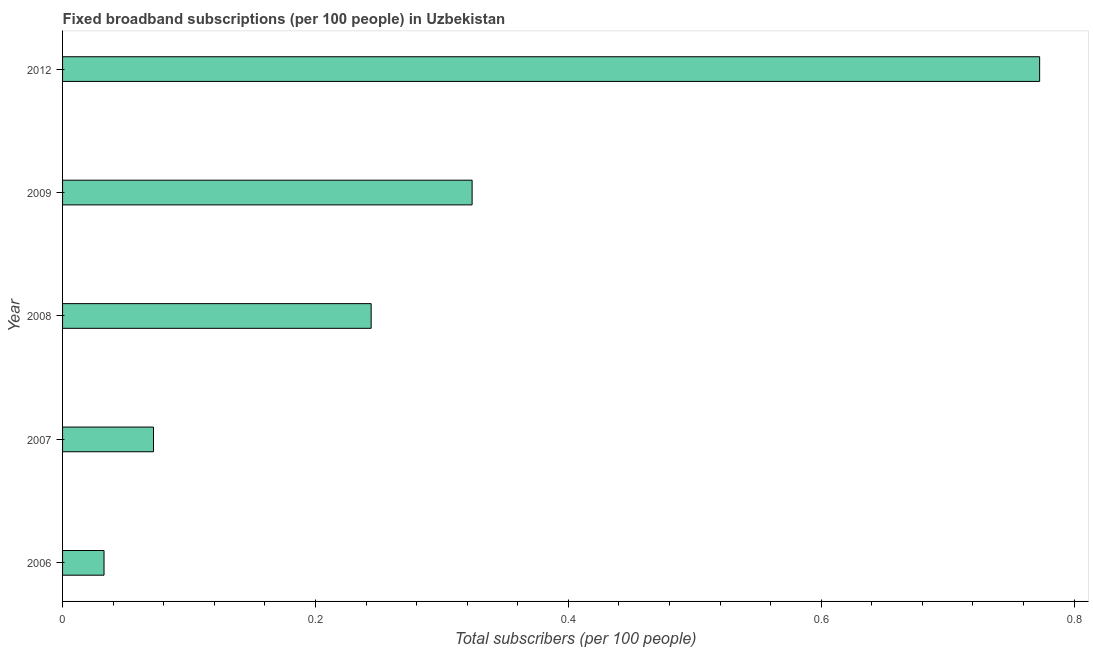Does the graph contain any zero values?
Offer a very short reply. No. Does the graph contain grids?
Provide a short and direct response. No. What is the title of the graph?
Offer a very short reply. Fixed broadband subscriptions (per 100 people) in Uzbekistan. What is the label or title of the X-axis?
Keep it short and to the point. Total subscribers (per 100 people). What is the label or title of the Y-axis?
Provide a succinct answer. Year. What is the total number of fixed broadband subscriptions in 2008?
Your response must be concise. 0.24. Across all years, what is the maximum total number of fixed broadband subscriptions?
Give a very brief answer. 0.77. Across all years, what is the minimum total number of fixed broadband subscriptions?
Your answer should be very brief. 0.03. In which year was the total number of fixed broadband subscriptions maximum?
Give a very brief answer. 2012. What is the sum of the total number of fixed broadband subscriptions?
Provide a short and direct response. 1.45. What is the difference between the total number of fixed broadband subscriptions in 2006 and 2009?
Your response must be concise. -0.29. What is the average total number of fixed broadband subscriptions per year?
Your answer should be very brief. 0.29. What is the median total number of fixed broadband subscriptions?
Your response must be concise. 0.24. In how many years, is the total number of fixed broadband subscriptions greater than 0.2 ?
Offer a very short reply. 3. What is the ratio of the total number of fixed broadband subscriptions in 2007 to that in 2012?
Provide a short and direct response. 0.09. Is the total number of fixed broadband subscriptions in 2006 less than that in 2009?
Offer a very short reply. Yes. What is the difference between the highest and the second highest total number of fixed broadband subscriptions?
Your response must be concise. 0.45. What is the difference between the highest and the lowest total number of fixed broadband subscriptions?
Offer a very short reply. 0.74. Are all the bars in the graph horizontal?
Offer a terse response. Yes. What is the difference between two consecutive major ticks on the X-axis?
Provide a succinct answer. 0.2. What is the Total subscribers (per 100 people) of 2006?
Ensure brevity in your answer.  0.03. What is the Total subscribers (per 100 people) of 2007?
Provide a succinct answer. 0.07. What is the Total subscribers (per 100 people) in 2008?
Keep it short and to the point. 0.24. What is the Total subscribers (per 100 people) of 2009?
Your response must be concise. 0.32. What is the Total subscribers (per 100 people) in 2012?
Your response must be concise. 0.77. What is the difference between the Total subscribers (per 100 people) in 2006 and 2007?
Offer a very short reply. -0.04. What is the difference between the Total subscribers (per 100 people) in 2006 and 2008?
Offer a terse response. -0.21. What is the difference between the Total subscribers (per 100 people) in 2006 and 2009?
Your answer should be compact. -0.29. What is the difference between the Total subscribers (per 100 people) in 2006 and 2012?
Provide a succinct answer. -0.74. What is the difference between the Total subscribers (per 100 people) in 2007 and 2008?
Offer a terse response. -0.17. What is the difference between the Total subscribers (per 100 people) in 2007 and 2009?
Ensure brevity in your answer.  -0.25. What is the difference between the Total subscribers (per 100 people) in 2007 and 2012?
Provide a short and direct response. -0.7. What is the difference between the Total subscribers (per 100 people) in 2008 and 2009?
Keep it short and to the point. -0.08. What is the difference between the Total subscribers (per 100 people) in 2008 and 2012?
Give a very brief answer. -0.53. What is the difference between the Total subscribers (per 100 people) in 2009 and 2012?
Your answer should be compact. -0.45. What is the ratio of the Total subscribers (per 100 people) in 2006 to that in 2007?
Provide a succinct answer. 0.46. What is the ratio of the Total subscribers (per 100 people) in 2006 to that in 2008?
Ensure brevity in your answer.  0.13. What is the ratio of the Total subscribers (per 100 people) in 2006 to that in 2009?
Give a very brief answer. 0.1. What is the ratio of the Total subscribers (per 100 people) in 2006 to that in 2012?
Your answer should be very brief. 0.04. What is the ratio of the Total subscribers (per 100 people) in 2007 to that in 2008?
Make the answer very short. 0.29. What is the ratio of the Total subscribers (per 100 people) in 2007 to that in 2009?
Ensure brevity in your answer.  0.22. What is the ratio of the Total subscribers (per 100 people) in 2007 to that in 2012?
Keep it short and to the point. 0.09. What is the ratio of the Total subscribers (per 100 people) in 2008 to that in 2009?
Keep it short and to the point. 0.75. What is the ratio of the Total subscribers (per 100 people) in 2008 to that in 2012?
Offer a very short reply. 0.32. What is the ratio of the Total subscribers (per 100 people) in 2009 to that in 2012?
Ensure brevity in your answer.  0.42. 